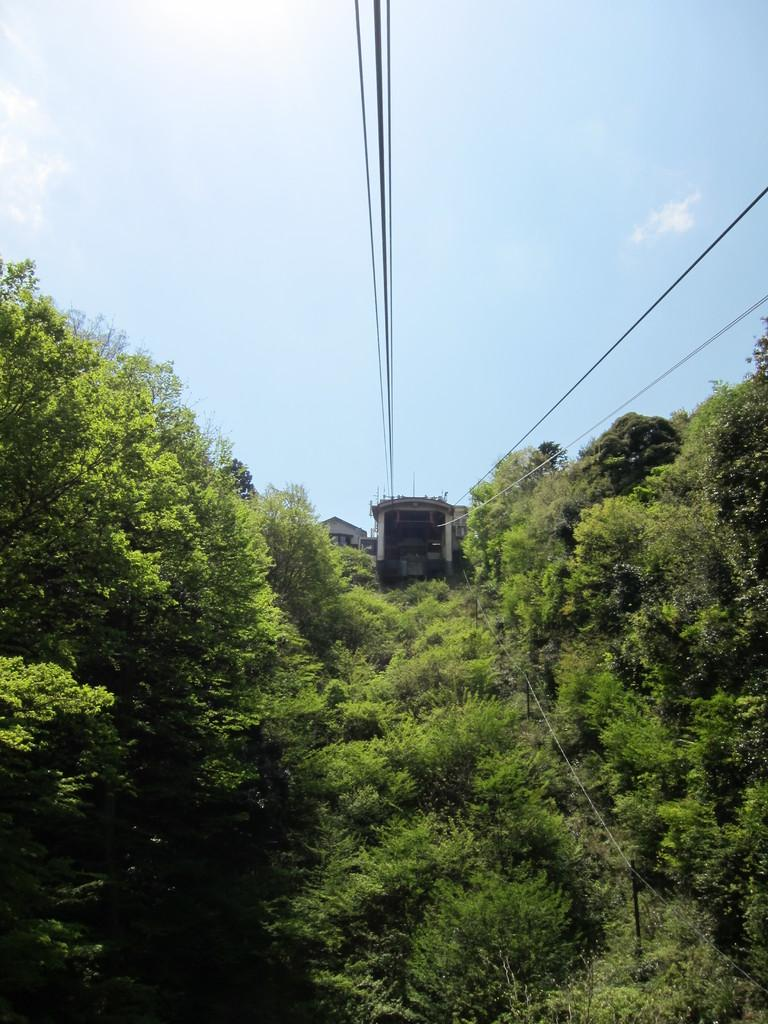What type of vegetation is present at the bottom of the picture? There are trees at the bottom of the picture. What type of structures can be seen in the background of the picture? There are buildings in the background of the picture. What is visible at the top of the picture? The sky is visible at the top of the picture. What else can be seen at the top of the picture besides the sky? There are wires visible at the top of the picture. What type of smell can be detected in the image? There is no information about smells in the image, so it cannot be determined. Can you describe the hall in the image? There is no hall present in the image; it features trees, buildings, sky, and wires. 